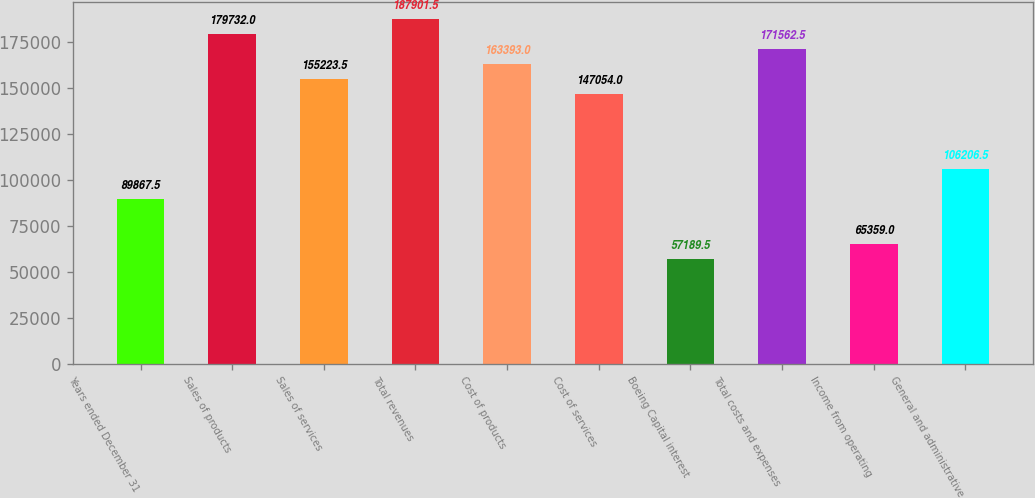Convert chart. <chart><loc_0><loc_0><loc_500><loc_500><bar_chart><fcel>Years ended December 31<fcel>Sales of products<fcel>Sales of services<fcel>Total revenues<fcel>Cost of products<fcel>Cost of services<fcel>Boeing Capital interest<fcel>Total costs and expenses<fcel>Income from operating<fcel>General and administrative<nl><fcel>89867.5<fcel>179732<fcel>155224<fcel>187902<fcel>163393<fcel>147054<fcel>57189.5<fcel>171562<fcel>65359<fcel>106206<nl></chart> 